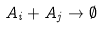<formula> <loc_0><loc_0><loc_500><loc_500>A _ { i } + A _ { j } \to \emptyset</formula> 